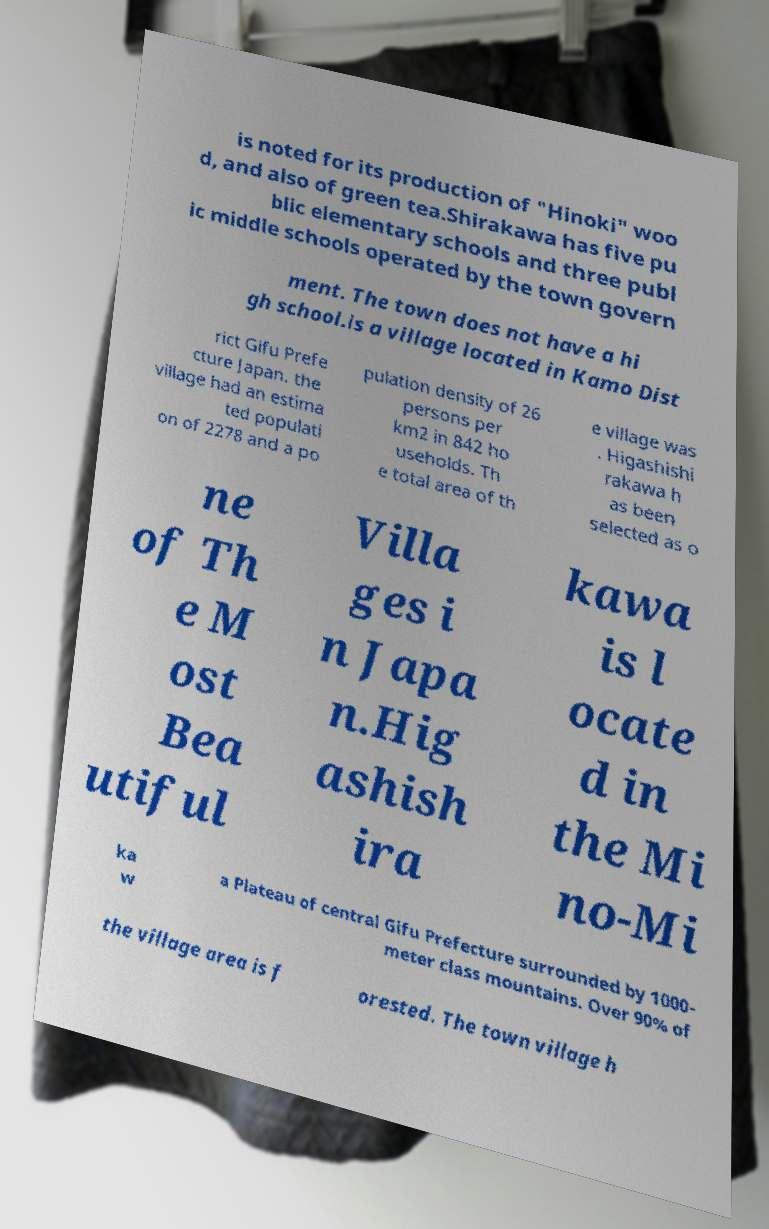I need the written content from this picture converted into text. Can you do that? is noted for its production of "Hinoki" woo d, and also of green tea.Shirakawa has five pu blic elementary schools and three publ ic middle schools operated by the town govern ment. The town does not have a hi gh school.is a village located in Kamo Dist rict Gifu Prefe cture Japan. the village had an estima ted populati on of 2278 and a po pulation density of 26 persons per km2 in 842 ho useholds. Th e total area of th e village was . Higashishi rakawa h as been selected as o ne of Th e M ost Bea utiful Villa ges i n Japa n.Hig ashish ira kawa is l ocate d in the Mi no-Mi ka w a Plateau of central Gifu Prefecture surrounded by 1000- meter class mountains. Over 90% of the village area is f orested. The town village h 